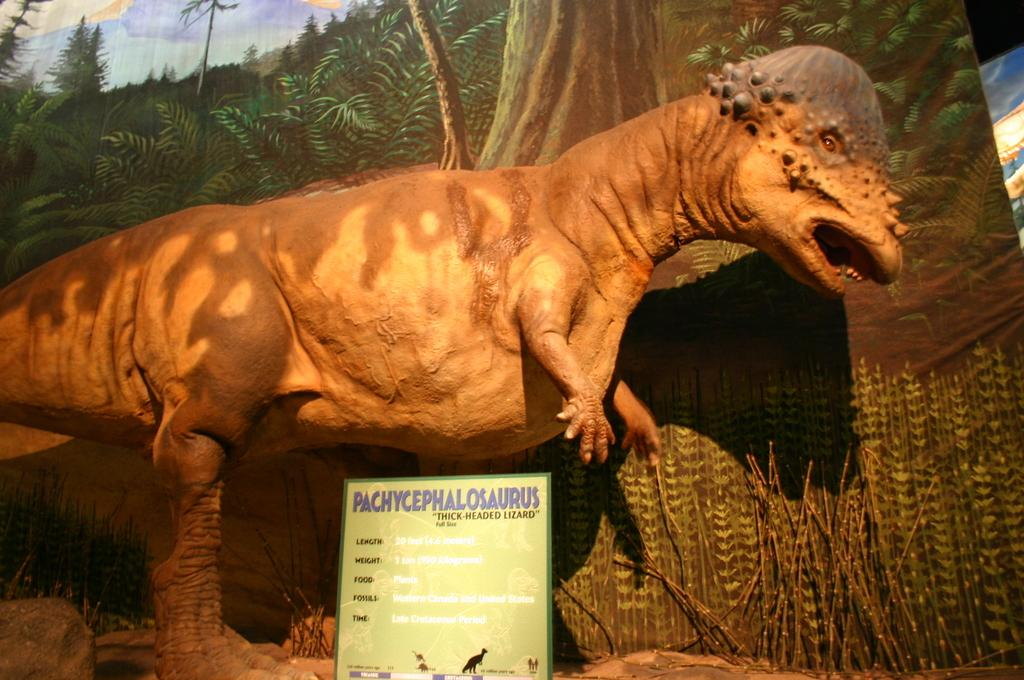What is the main subject of the image? There is a sculpture of a dinosaur in the image. What is in front of the dinosaur sculpture? There is a board in front of the dinosaur sculpture. What can be seen at the back of the image? There is a curtain at the back of the image, and it has a painting of trees. What is on the left side of the image? There is a rock on the left side of the image. How much sugar is present in the image? There is no sugar present in the image. Can you tell me the name of the sister of the dinosaur sculpture? There is no sister of the dinosaur sculpture mentioned or depicted in the image. 